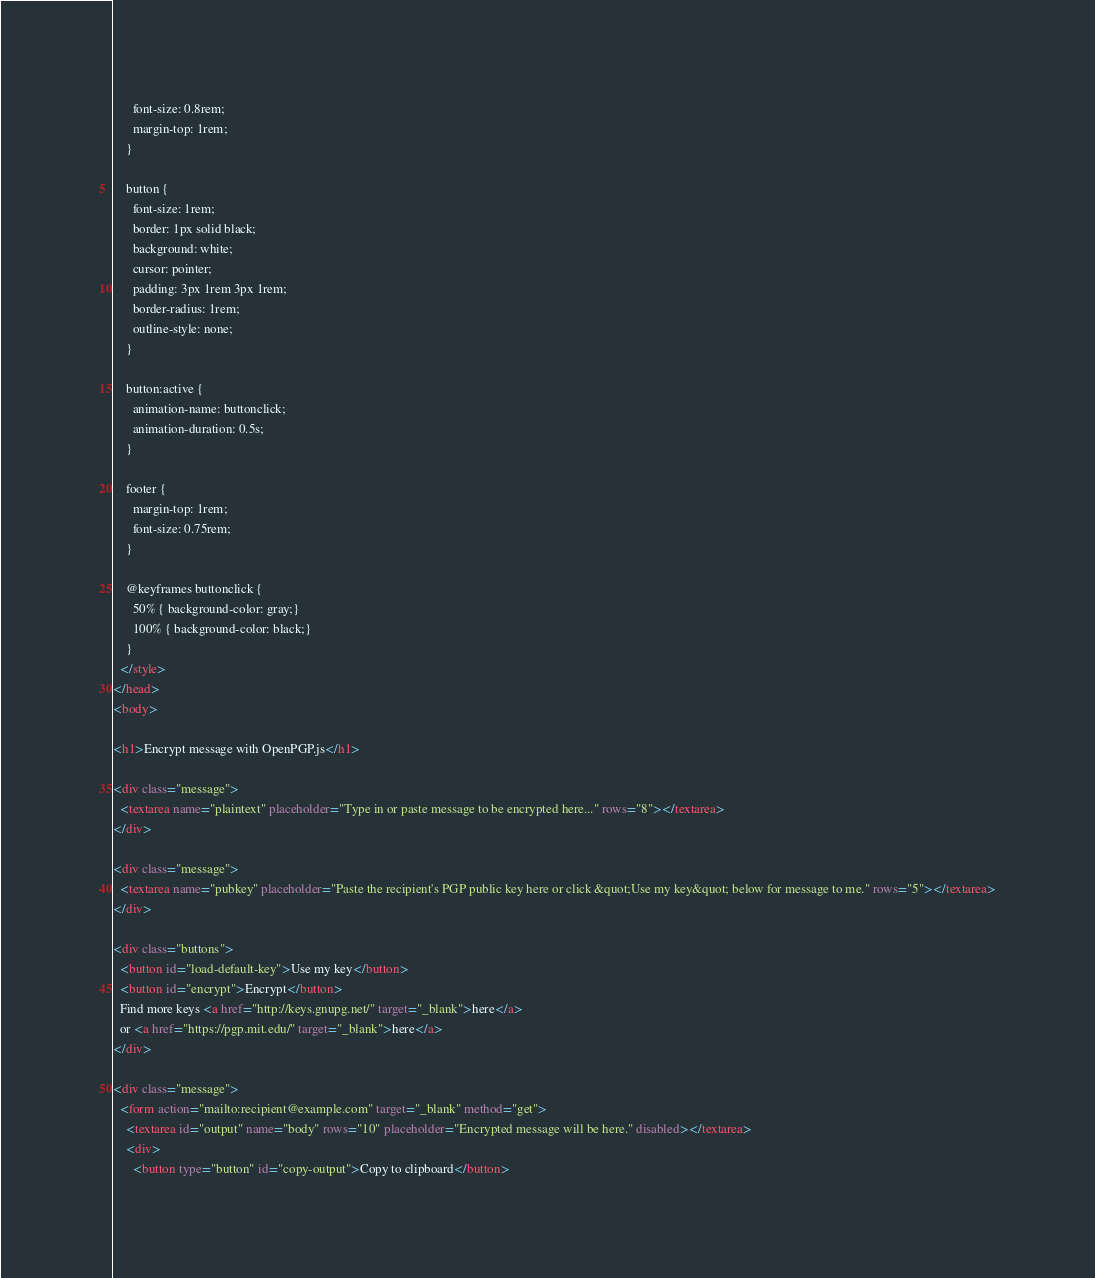<code> <loc_0><loc_0><loc_500><loc_500><_HTML_>      font-size: 0.8rem;
      margin-top: 1rem;
    }

    button {
      font-size: 1rem;
      border: 1px solid black;
      background: white;
      cursor: pointer;
      padding: 3px 1rem 3px 1rem;
      border-radius: 1rem;
      outline-style: none;
    }

    button:active {
      animation-name: buttonclick;
      animation-duration: 0.5s;
    }

    footer {
      margin-top: 1rem;
      font-size: 0.75rem;
    }

    @keyframes buttonclick {
      50% { background-color: gray;}
      100% { background-color: black;}
    }
  </style>
</head>
<body>

<h1>Encrypt message with OpenPGP.js</h1>

<div class="message">
  <textarea name="plaintext" placeholder="Type in or paste message to be encrypted here..." rows="8"></textarea>
</div>

<div class="message">
  <textarea name="pubkey" placeholder="Paste the recipient's PGP public key here or click &quot;Use my key&quot; below for message to me." rows="5"></textarea>
</div>

<div class="buttons">
  <button id="load-default-key">Use my key</button>
  <button id="encrypt">Encrypt</button>
  Find more keys <a href="http://keys.gnupg.net/" target="_blank">here</a> 
  or <a href="https://pgp.mit.edu/" target="_blank">here</a>
</div>

<div class="message">
  <form action="mailto:recipient@example.com" target="_blank" method="get">
    <textarea id="output" name="body" rows="10" placeholder="Encrypted message will be here." disabled></textarea>
    <div>
      <button type="button" id="copy-output">Copy to clipboard</button></code> 